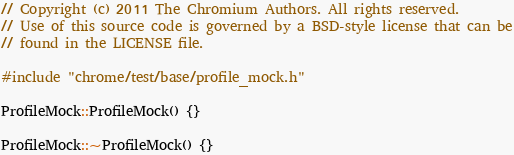Convert code to text. <code><loc_0><loc_0><loc_500><loc_500><_C++_>// Copyright (c) 2011 The Chromium Authors. All rights reserved.
// Use of this source code is governed by a BSD-style license that can be
// found in the LICENSE file.

#include "chrome/test/base/profile_mock.h"

ProfileMock::ProfileMock() {}

ProfileMock::~ProfileMock() {}
</code> 